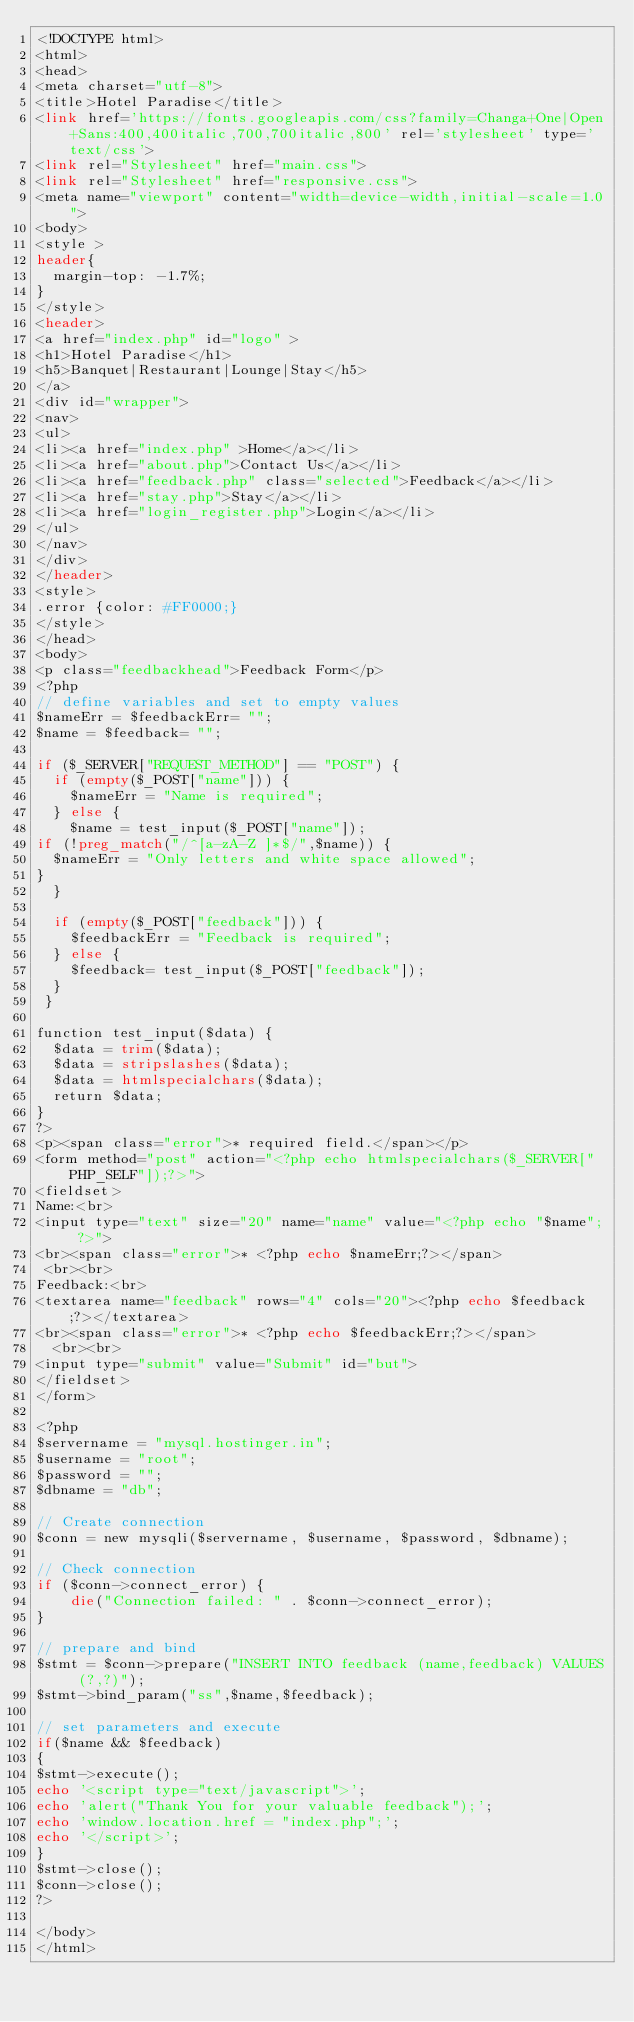<code> <loc_0><loc_0><loc_500><loc_500><_PHP_><!DOCTYPE html>
<html>
<head>
<meta charset="utf-8">
<title>Hotel Paradise</title>
<link href='https://fonts.googleapis.com/css?family=Changa+One|Open+Sans:400,400italic,700,700italic,800' rel='stylesheet' type='text/css'>
<link rel="Stylesheet" href="main.css">
<link rel="Stylesheet" href="responsive.css">
<meta name="viewport" content="width=device-width,initial-scale=1.0">
<body>  
<style >
header{
  margin-top: -1.7%;
}
</style>
<header>  
<a href="index.php" id="logo" >
<h1>Hotel Paradise</h1>
<h5>Banquet|Restaurant|Lounge|Stay</h5>
</a>  
<div id="wrapper">
<nav>
<ul>
<li><a href="index.php" >Home</a></li>
<li><a href="about.php">Contact Us</a></li>
<li><a href="feedback.php" class="selected">Feedback</a></li>
<li><a href="stay.php">Stay</a></li>
<li><a href="login_register.php">Login</a></li>
</ul>
</nav>
</div>
</header>
<style>
.error {color: #FF0000;}
</style>
</head>
<body>
<p class="feedbackhead">Feedback Form</p>
<?php
// define variables and set to empty values
$nameErr = $feedbackErr= "";
$name = $feedback= "";

if ($_SERVER["REQUEST_METHOD"] == "POST") {
  if (empty($_POST["name"])) {
    $nameErr = "Name is required";
  } else {
    $name = test_input($_POST["name"]);
if (!preg_match("/^[a-zA-Z ]*$/",$name)) {
  $nameErr = "Only letters and white space allowed"; 
}  
  }
  
  if (empty($_POST["feedback"])) {
    $feedbackErr = "Feedback is required";
  } else {
    $feedback= test_input($_POST["feedback"]);
  }
 }

function test_input($data) {
  $data = trim($data);
  $data = stripslashes($data);
  $data = htmlspecialchars($data);
  return $data;
}
?>
<p><span class="error">* required field.</span></p>
<form method="post" action="<?php echo htmlspecialchars($_SERVER["PHP_SELF"]);?>"> 
<fieldset>
Name:<br>
<input type="text" size="20" name="name" value="<?php echo "$name"; ?>">
<br><span class="error">* <?php echo $nameErr;?></span>
 <br><br>
Feedback:<br>
<textarea name="feedback" rows="4" cols="20"><?php echo $feedback;?></textarea>
<br><span class="error">* <?php echo $feedbackErr;?></span>
  <br><br>
<input type="submit" value="Submit" id="but">
</fieldset>
</form>

<?php
$servername = "mysql.hostinger.in";
$username = "root";
$password = "";
$dbname = "db";

// Create connection
$conn = new mysqli($servername, $username, $password, $dbname);

// Check connection
if ($conn->connect_error) {
    die("Connection failed: " . $conn->connect_error);
}

// prepare and bind
$stmt = $conn->prepare("INSERT INTO feedback (name,feedback) VALUES (?,?)");
$stmt->bind_param("ss",$name,$feedback);

// set parameters and execute
if($name && $feedback)
{
$stmt->execute();
echo '<script type="text/javascript">'; 
echo 'alert("Thank You for your valuable feedback");'; 
echo 'window.location.href = "index.php";';
echo '</script>';
}
$stmt->close();
$conn->close();
?>

</body>
</html></code> 